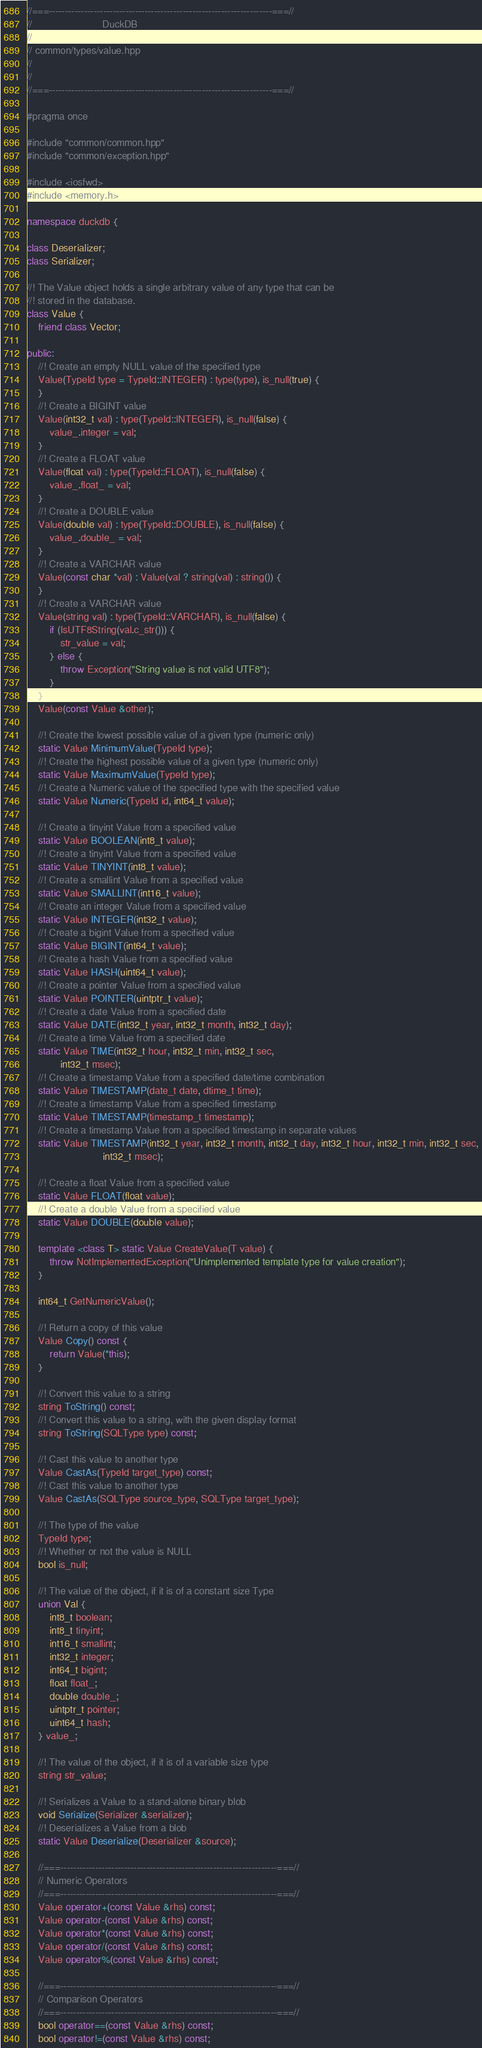Convert code to text. <code><loc_0><loc_0><loc_500><loc_500><_C++_>//===----------------------------------------------------------------------===//
//                         DuckDB
//
// common/types/value.hpp
//
//
//===----------------------------------------------------------------------===//

#pragma once

#include "common/common.hpp"
#include "common/exception.hpp"

#include <iosfwd>
#include <memory.h>

namespace duckdb {

class Deserializer;
class Serializer;

//! The Value object holds a single arbitrary value of any type that can be
//! stored in the database.
class Value {
	friend class Vector;

public:
	//! Create an empty NULL value of the specified type
	Value(TypeId type = TypeId::INTEGER) : type(type), is_null(true) {
	}
	//! Create a BIGINT value
	Value(int32_t val) : type(TypeId::INTEGER), is_null(false) {
		value_.integer = val;
	}
	//! Create a FLOAT value
	Value(float val) : type(TypeId::FLOAT), is_null(false) {
		value_.float_ = val;
	}
	//! Create a DOUBLE value
	Value(double val) : type(TypeId::DOUBLE), is_null(false) {
		value_.double_ = val;
	}
	//! Create a VARCHAR value
	Value(const char *val) : Value(val ? string(val) : string()) {
	}
	//! Create a VARCHAR value
	Value(string val) : type(TypeId::VARCHAR), is_null(false) {
		if (IsUTF8String(val.c_str())) {
			str_value = val;
		} else {
			throw Exception("String value is not valid UTF8");
		}
	}
	Value(const Value &other);

	//! Create the lowest possible value of a given type (numeric only)
	static Value MinimumValue(TypeId type);
	//! Create the highest possible value of a given type (numeric only)
	static Value MaximumValue(TypeId type);
	//! Create a Numeric value of the specified type with the specified value
	static Value Numeric(TypeId id, int64_t value);

	//! Create a tinyint Value from a specified value
	static Value BOOLEAN(int8_t value);
	//! Create a tinyint Value from a specified value
	static Value TINYINT(int8_t value);
	//! Create a smallint Value from a specified value
	static Value SMALLINT(int16_t value);
	//! Create an integer Value from a specified value
	static Value INTEGER(int32_t value);
	//! Create a bigint Value from a specified value
	static Value BIGINT(int64_t value);
	//! Create a hash Value from a specified value
	static Value HASH(uint64_t value);
	//! Create a pointer Value from a specified value
	static Value POINTER(uintptr_t value);
	//! Create a date Value from a specified date
	static Value DATE(int32_t year, int32_t month, int32_t day);
	//! Create a time Value from a specified date
	static Value TIME(int32_t hour, int32_t min, int32_t sec,
            int32_t msec);
	//! Create a timestamp Value from a specified date/time combination
	static Value TIMESTAMP(date_t date, dtime_t time);
	//! Create a timestamp Value from a specified timestamp
	static Value TIMESTAMP(timestamp_t timestamp);
	//! Create a timestamp Value from a specified timestamp in separate values
	static Value TIMESTAMP(int32_t year, int32_t month, int32_t day, int32_t hour, int32_t min, int32_t sec,
	                       int32_t msec);

	//! Create a float Value from a specified value
	static Value FLOAT(float value);
	//! Create a double Value from a specified value
	static Value DOUBLE(double value);

	template <class T> static Value CreateValue(T value) {
		throw NotImplementedException("Unimplemented template type for value creation");
	}

	int64_t GetNumericValue();

	//! Return a copy of this value
	Value Copy() const {
		return Value(*this);
	}

	//! Convert this value to a string
	string ToString() const;
	//! Convert this value to a string, with the given display format
	string ToString(SQLType type) const;

	//! Cast this value to another type
	Value CastAs(TypeId target_type) const;
	//! Cast this value to another type
	Value CastAs(SQLType source_type, SQLType target_type);

	//! The type of the value
	TypeId type;
	//! Whether or not the value is NULL
	bool is_null;

	//! The value of the object, if it is of a constant size Type
	union Val {
		int8_t boolean;
		int8_t tinyint;
		int16_t smallint;
		int32_t integer;
		int64_t bigint;
		float float_;
		double double_;
		uintptr_t pointer;
		uint64_t hash;
	} value_;

	//! The value of the object, if it is of a variable size type
	string str_value;

	//! Serializes a Value to a stand-alone binary blob
	void Serialize(Serializer &serializer);
	//! Deserializes a Value from a blob
	static Value Deserialize(Deserializer &source);

	//===--------------------------------------------------------------------===//
	// Numeric Operators
	//===--------------------------------------------------------------------===//
	Value operator+(const Value &rhs) const;
	Value operator-(const Value &rhs) const;
	Value operator*(const Value &rhs) const;
	Value operator/(const Value &rhs) const;
	Value operator%(const Value &rhs) const;

	//===--------------------------------------------------------------------===//
	// Comparison Operators
	//===--------------------------------------------------------------------===//
	bool operator==(const Value &rhs) const;
	bool operator!=(const Value &rhs) const;</code> 